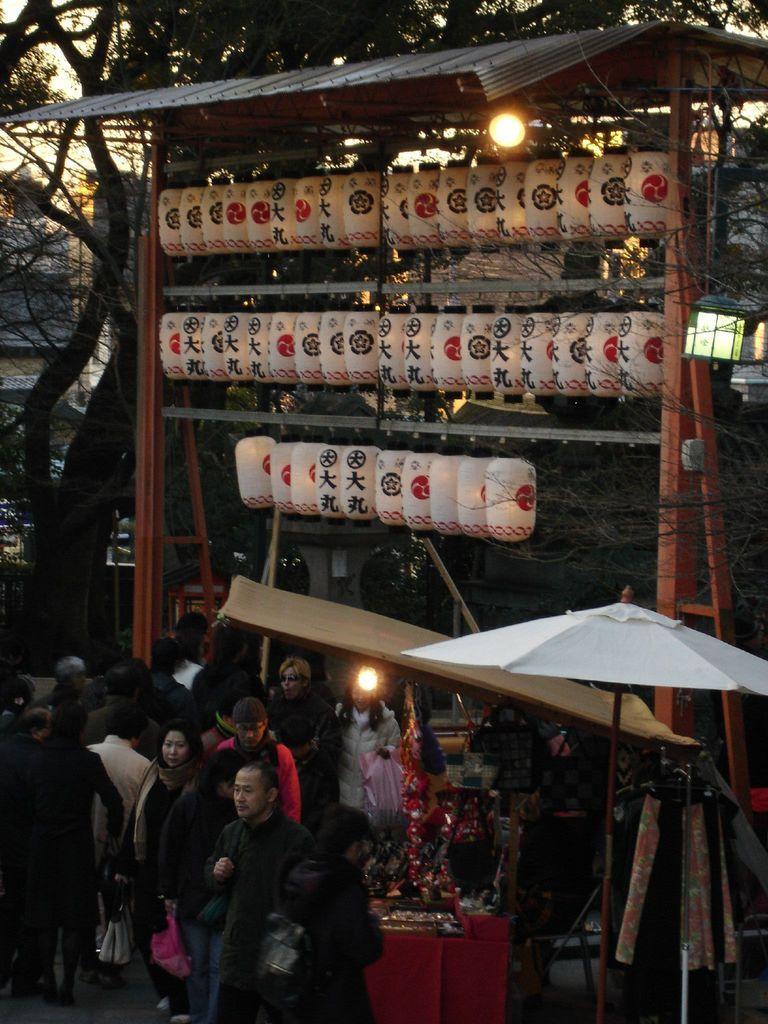Can you describe this image briefly? In the image there are some objects attached to the wooden sticks under a shelter and around those wooden sticks there are a lot of people and beside them there are some stores, in the background there is a tree. 